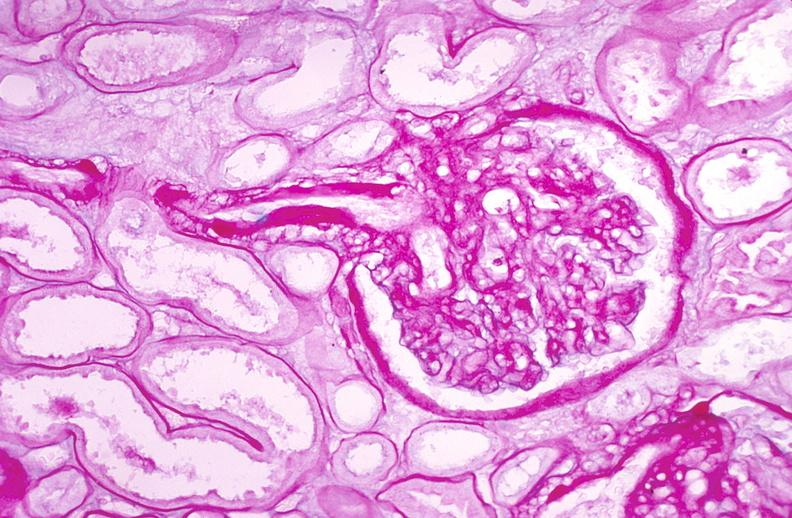where is this?
Answer the question using a single word or phrase. Urinary 